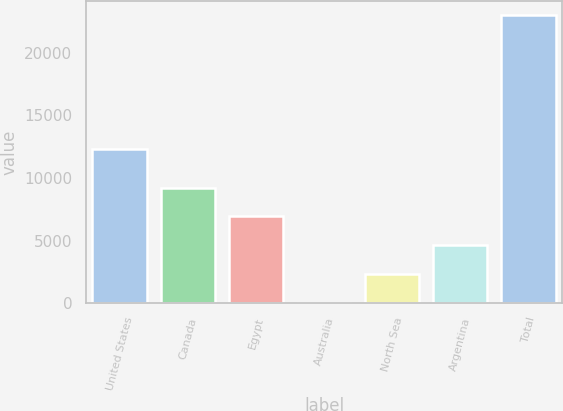Convert chart to OTSL. <chart><loc_0><loc_0><loc_500><loc_500><bar_chart><fcel>United States<fcel>Canada<fcel>Egypt<fcel>Australia<fcel>North Sea<fcel>Argentina<fcel>Total<nl><fcel>12341<fcel>9226.6<fcel>6928.2<fcel>33<fcel>2331.4<fcel>4629.8<fcel>23017<nl></chart> 